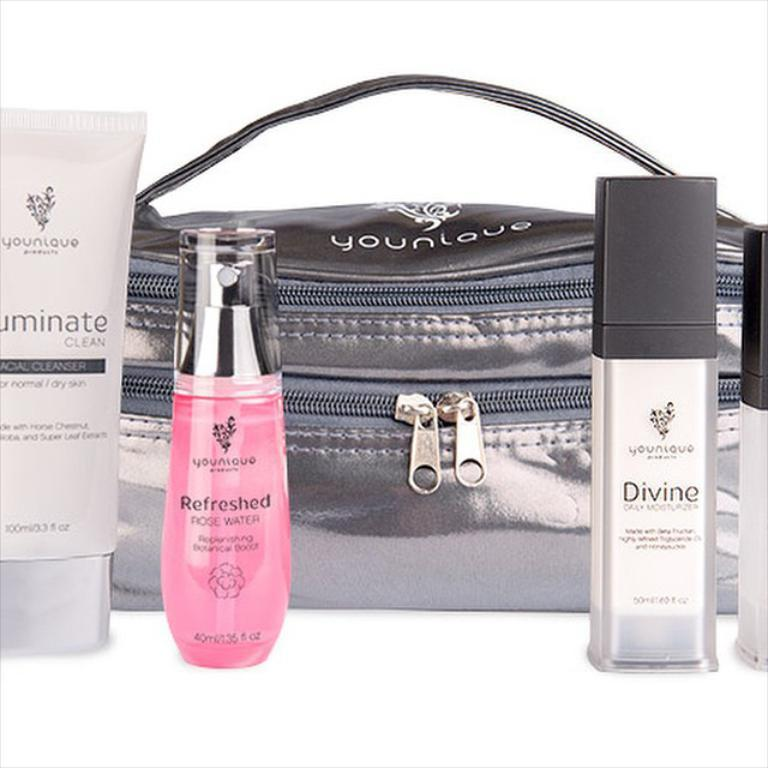What type of animal might be present in the image? It is impossible to determine the presence of any specific animal without any facts about the image. What architectural feature might be visible in the image? It is impossible to determine the presence of any specific architectural feature without any facts about the image. What type of emotion might the image evoke? It is impossible to determine the emotion evoked by the image without any facts about the image. Reasoning: Since there are no facts provided about an image, we cannot create a conversation based on specific details. However, we can still create diverse questions based on general assumptions about a potential image. We formulate questions that focus on the possible presence of an animal, an architectural feature, and the emotion evoked by the image. Each question is designed to elicit a specific detail about the image that is not known from the provided facts. Absurd Question/Answer: How does the hen feel about the thrill of the arch in the image? There is no hen, thrill, or arch present in the image, so it is not possible to answer that question. How does the hen feel about the thrill of the arch in the image? There is no hen, thrill, or arch present in the image, so it is not possible to answer that question. Reasoning: Let's think step by step in order to create the conversation. We acknowledge that there are no facts provided about an image, so we cannot create a conversation based on specific details. Instead, we create diverse questions based on general assumptions about a potential image. We formulate questions that focus on the possible presence of an animal, an architectural feature, and the emotion evoked by the image. Each question is designed to elicit a specific detail about the image that is not known from the provided facts. We also include an "absurd" question that is not present in the image, in this case, a question about a hen, thrill, and arch. We ensure that the language is simple and clear, and we avoid yes/no questions and questions that cannot be answered definitively. 